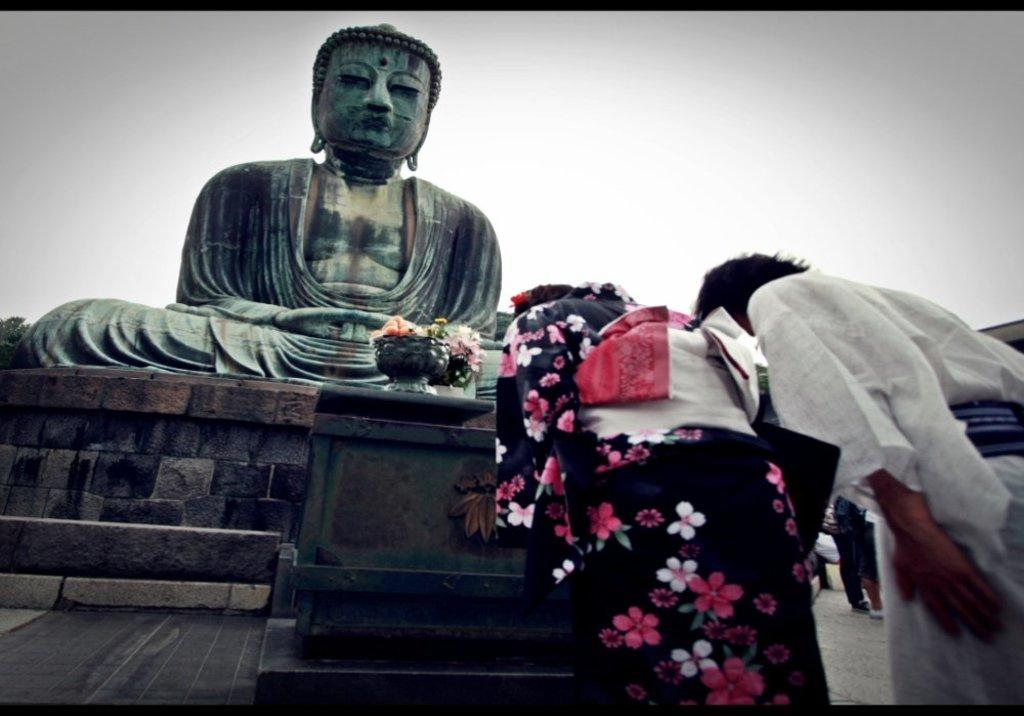What is the main subject in the image? There is a statue of a person in the image. Are there any other people present in the image? Yes, there are two persons standing at the right side of the image. What can be seen in the background of the image? The sky is clear in the background of the image. How many snakes are wrapped around the statue in the image? There are no snakes present in the image; the statue is of a person. 